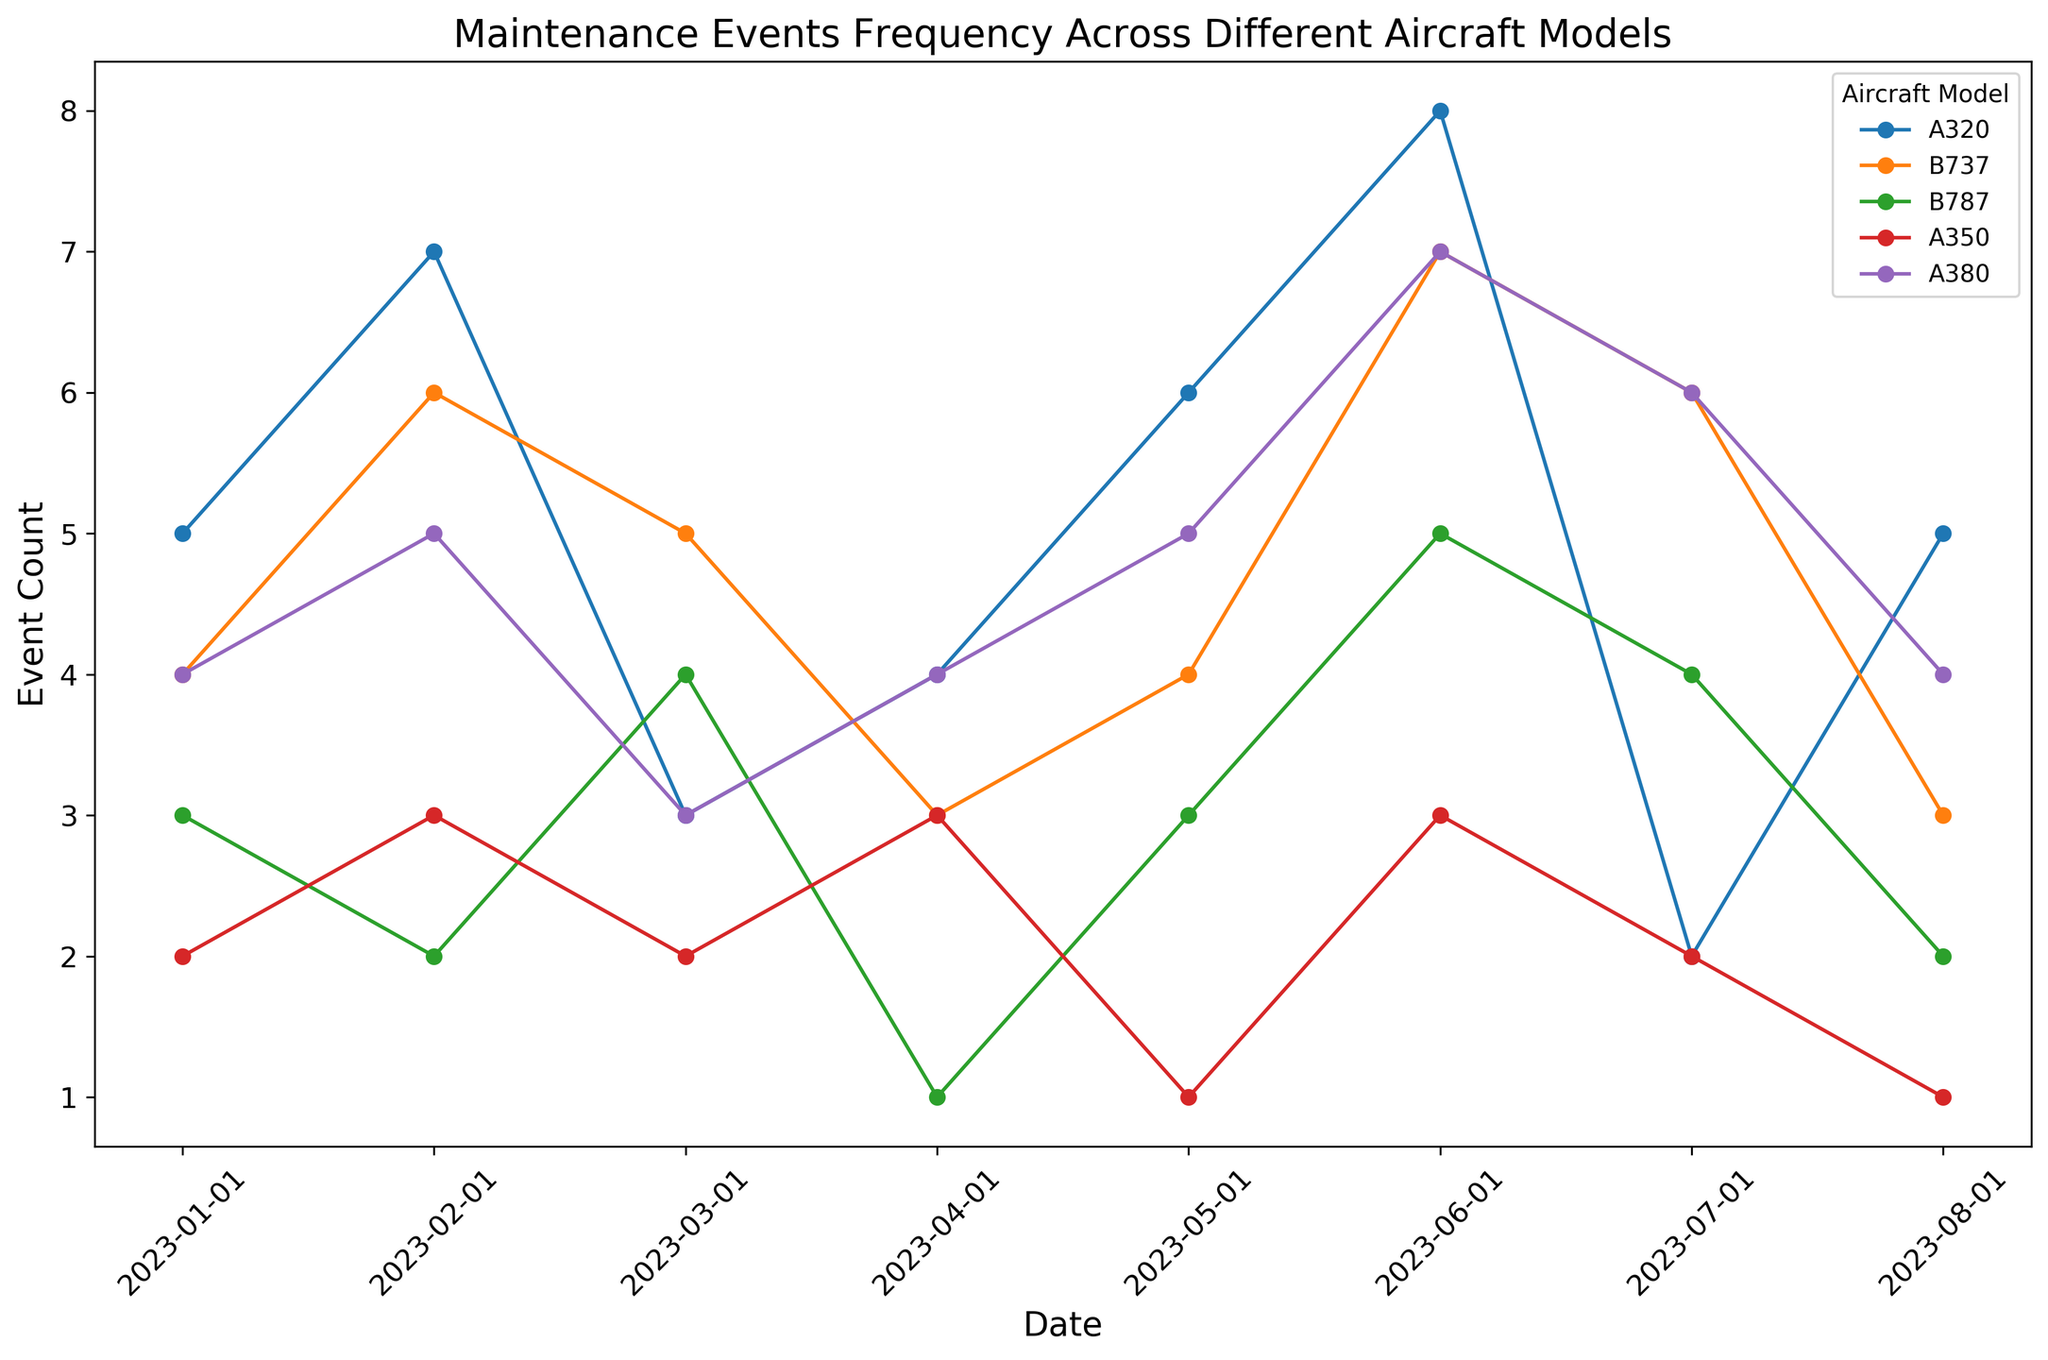Which aircraft model had the highest number of maintenance events in June 2023? From the plot, find the data point corresponding to June 2023 for each aircraft model. Compare the heights of the markers. The A320 had the highest event count in June 2023.
Answer: A320 How many more maintenance events did the A320 have in July 2023 compared to the A350? Identify the markers for A320 and A350 in July 2023, note their event counts (A320: 2, A350: 2), then subtract the event count for A350 from A320.
Answer: 0 Which aircraft model had the most consistent maintenance event frequency from January to August 2023? Observe the variability in the event counts for each model over the given months. The A350 shows less variance in its event counts compared to other models, indicating more consistency.
Answer: A350 During which month did the B737 and B787 both have the same number of maintenance events? For each month, compare the event counts of B737 and B787. Identify that in March 2023, both models have a count of 5 events.
Answer: March 2023 Calculate the total maintenance events for the A380 over the entire period. Sum the event counts of the A380 for all the months given, which are: 4 + 5 + 3 + 4 + 5 + 7 + 6 + 4 = 38
Answer: 38 In which month did the A350 experience its highest number of maintenance events? Identify the month where the A350 has the highest marker on the plot. The highest count (3 events) is in February and June 2023.
Answer: February 2023, June 2023 Compare the event counts of the A320 and A380 in January 2023. Which had more events and by how many? Find the event counts for A320 and A380 in January 2023 (A320: 5, A380: 4). Subtract A380’s event count from A320’s.
Answer: A320 had 1 more event What was the average number of events for the B787 from January to August 2023? Sum the events for B787 over these months (3 + 2 + 4 + 1 + 3 + 5 + 4 + 2 = 24). Divide the total by 8 months to get the average.
Answer: 3 Which aircraft model showed the largest increase in maintenance events between January and June 2023? For each model, calculate the difference in event counts between January and June. The A320 shows an increase from 5 to 8, a 3 event increase, which is the largest.
Answer: A320 In which month did the A350 have fewer maintenance events than the B737 but more than the B787? Compare event counts for each month. In April 2023, the A350 had 3 events, B737 had 3, and B787 had 1. So, there's no month matching these criteria; closest is May and June where A350 had fewer than B737 but more than B787, but not perfect match.
Answer: No perfect month 